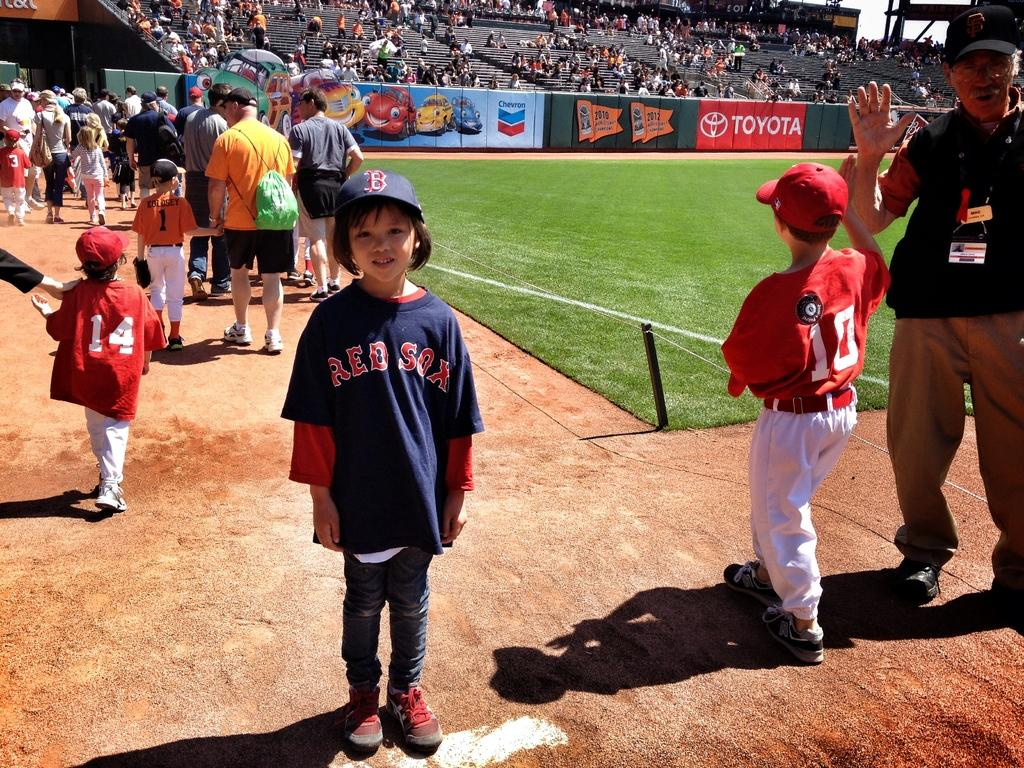Provide a one-sentence caption for the provided image. A young Red Sox fan stands in the bullpen. 